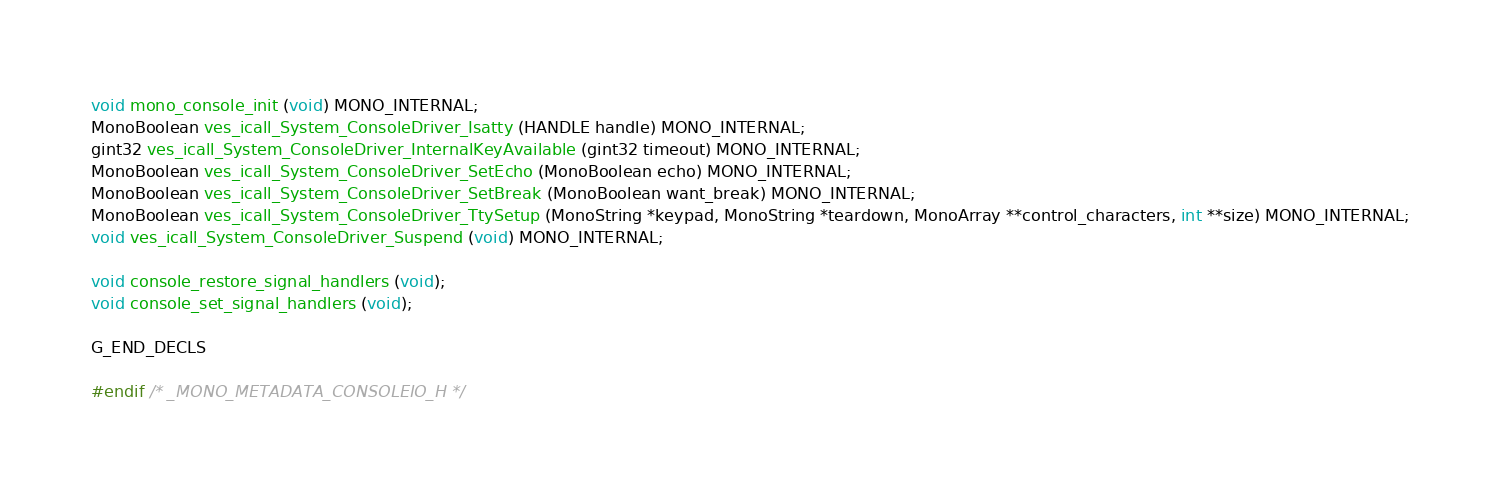<code> <loc_0><loc_0><loc_500><loc_500><_C_>void mono_console_init (void) MONO_INTERNAL;
MonoBoolean ves_icall_System_ConsoleDriver_Isatty (HANDLE handle) MONO_INTERNAL;
gint32 ves_icall_System_ConsoleDriver_InternalKeyAvailable (gint32 timeout) MONO_INTERNAL;
MonoBoolean ves_icall_System_ConsoleDriver_SetEcho (MonoBoolean echo) MONO_INTERNAL;
MonoBoolean ves_icall_System_ConsoleDriver_SetBreak (MonoBoolean want_break) MONO_INTERNAL;
MonoBoolean ves_icall_System_ConsoleDriver_TtySetup (MonoString *keypad, MonoString *teardown, MonoArray **control_characters, int **size) MONO_INTERNAL;
void ves_icall_System_ConsoleDriver_Suspend (void) MONO_INTERNAL;

void console_restore_signal_handlers (void);
void console_set_signal_handlers (void);

G_END_DECLS

#endif /* _MONO_METADATA_CONSOLEIO_H */

</code> 